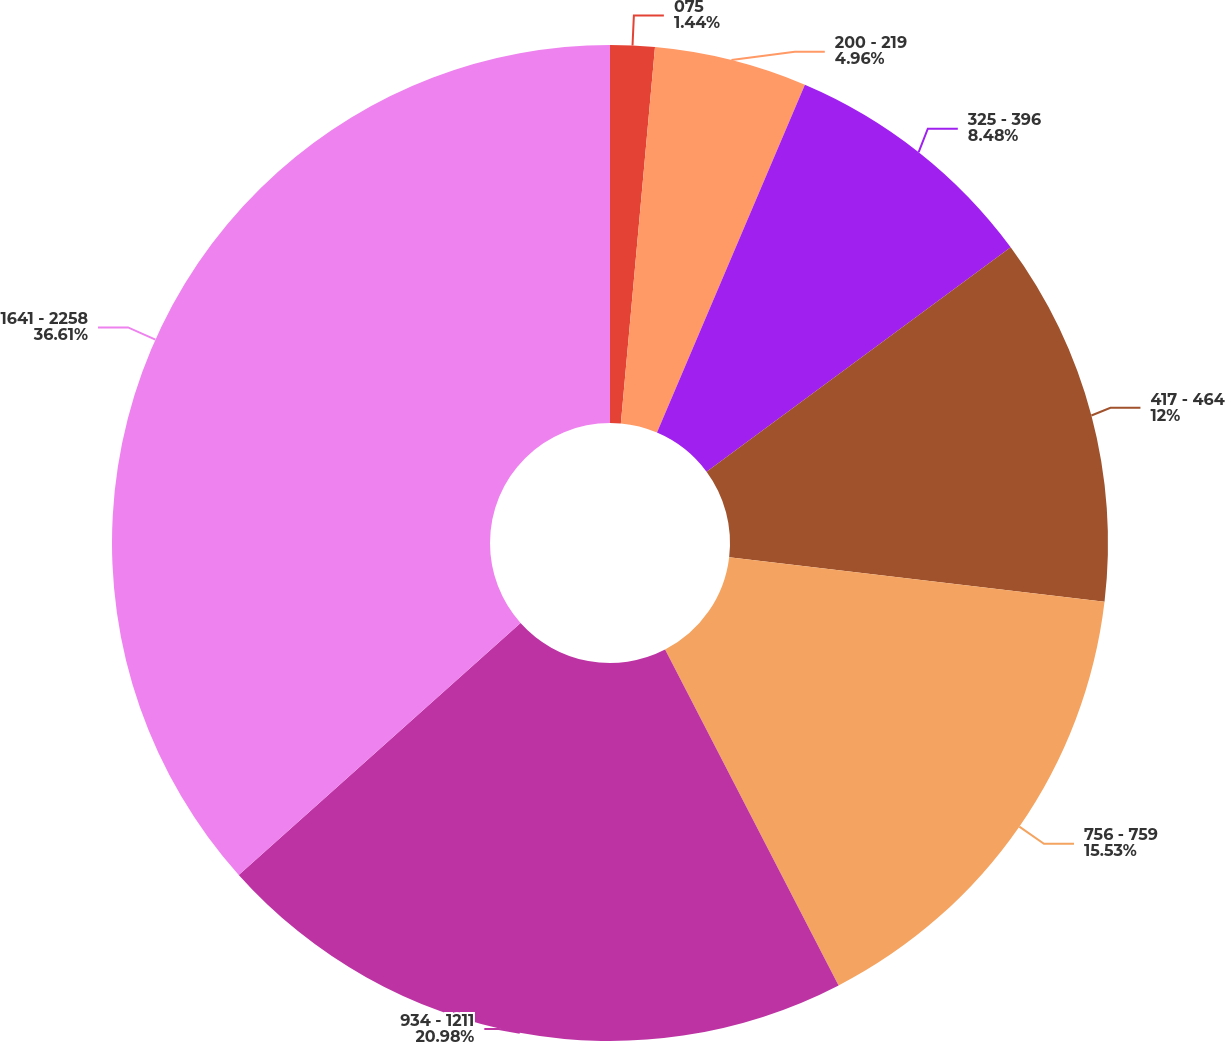Convert chart to OTSL. <chart><loc_0><loc_0><loc_500><loc_500><pie_chart><fcel>075<fcel>200 - 219<fcel>325 - 396<fcel>417 - 464<fcel>756 - 759<fcel>934 - 1211<fcel>1641 - 2258<nl><fcel>1.44%<fcel>4.96%<fcel>8.48%<fcel>12.0%<fcel>15.53%<fcel>20.98%<fcel>36.61%<nl></chart> 